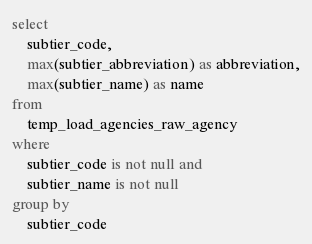Convert code to text. <code><loc_0><loc_0><loc_500><loc_500><_SQL_>select
    subtier_code,
    max(subtier_abbreviation) as abbreviation,
    max(subtier_name) as name
from
    temp_load_agencies_raw_agency
where
    subtier_code is not null and
    subtier_name is not null
group by
    subtier_code
</code> 